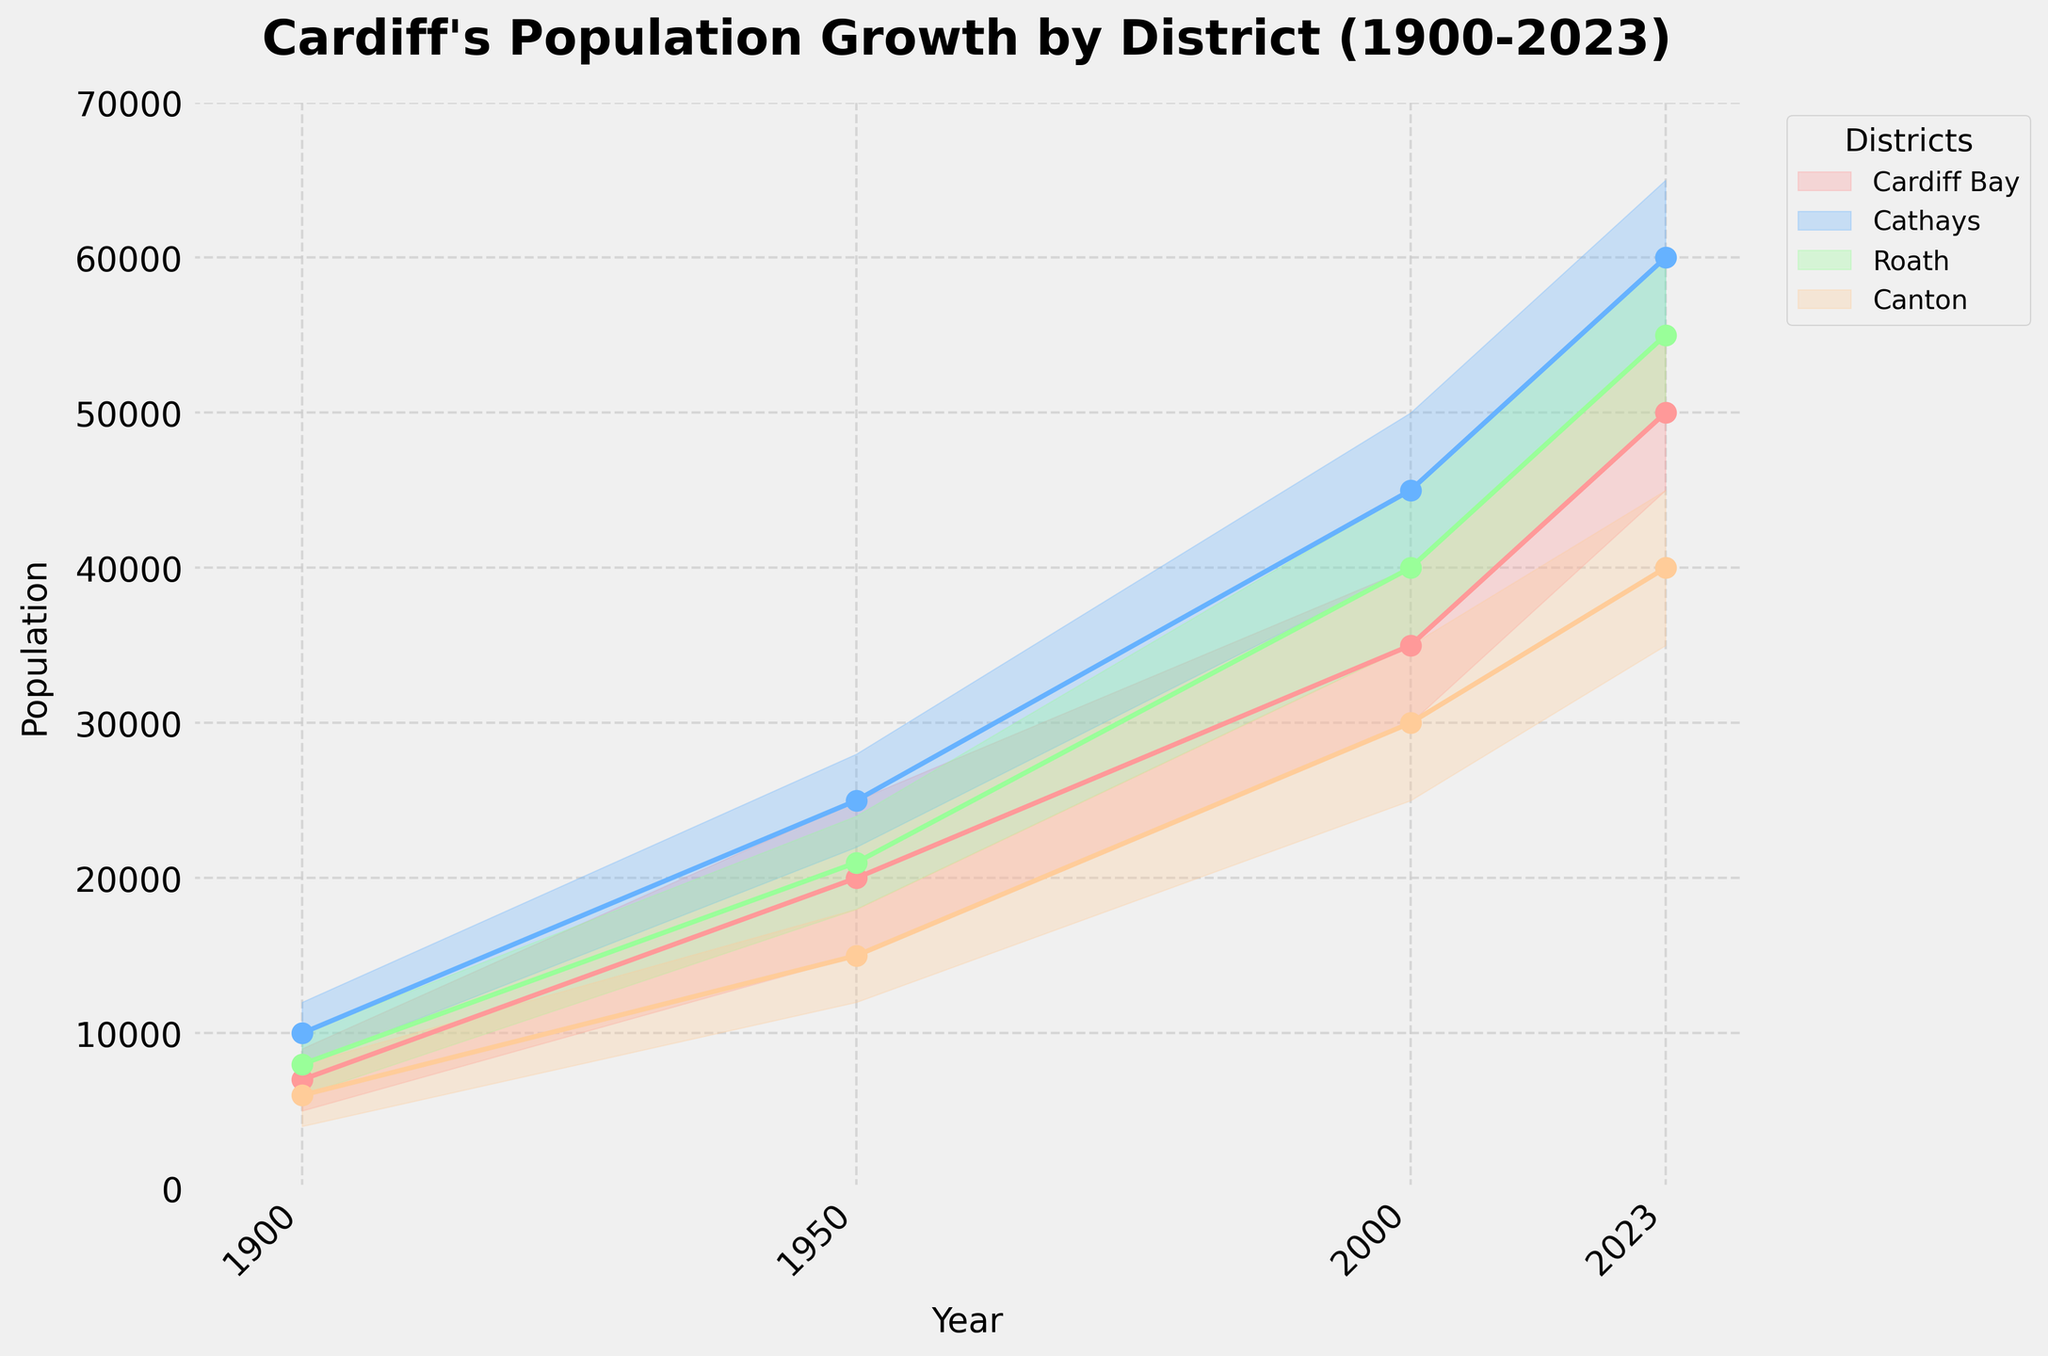What is the title of the chart? The chart's title is displayed at the top of the figure.
Answer: Cardiff's Population Growth by District (1900-2023) How many different districts are shown in the chart? The chart legend lists all the different districts represented by different colors.
Answer: Four What is the population range for Cardiff Bay in the year 1950? The fan chart shows the "Low" and "High" population values for each year. For 1950, Cardiff Bay's fan chart ranges from 15,000 to 25,000.
Answer: 15,000 to 25,000 Which district had the highest population in 2000? By checking the mid-points in 2000 for all districts, Cathays had the highest population with a mid-point around 45,000.
Answer: Cathays Compare the population growth of Roath and Canton between 1900 and 2023. Which has seen a greater increase? For Roath, the mid-point population grew from 8,000 in 1900 to 55,000 in 2023, an increase of 47,000. For Canton, the mid-point grew from 6,000 in 1900 to 40,000 in 2023, an increase of 34,000. Thus, Roath saw a greater increase.
Answer: Roath What is the population difference between Cathays and Cardiff Bay in 2023? In 2023, Cathays has a mid-point population of 60,000, and Cardiff Bay has a mid-point of 50,000. The difference is 60,000 - 50,000 = 10,000.
Answer: 10,000 What is the general trend of population in the Canton district over the period shown? Observing the Canton's population fan chart, it shows a consistent upward trend from 1900 to 2023, with the mid-point increasing from 6,000 to 40,000.
Answer: Increasing Which year showed the most significant population increase for Cathays? By comparing the mid-point populations at different intervals, from 1950 to 2000, Cathays saw the largest jump from 25,000 to 45,000, a change of 20,000.
Answer: 1950 to 2000 What is the average population range (Low to High) for Roath in the year 1900? The low point is 6,000 and the high point is 10,000, giving a range of 10,000 - 6,000 = 4,000.
Answer: 4,000 